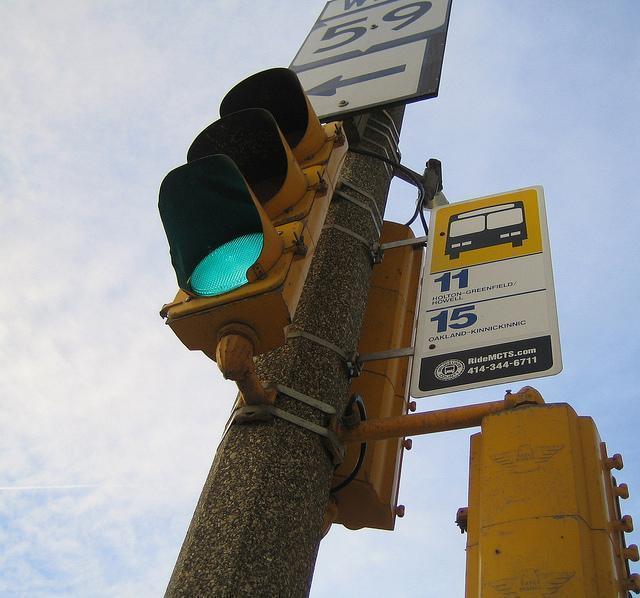What is the largest of the blue numbers on the sign?
Indicate the correct choice and explain in the format: 'Answer: answer
Rationale: rationale.'
Options: 98, 15, 77, 12. Answer: 15.
Rationale: As long as you can read and write you can tell which number is the greatest. 